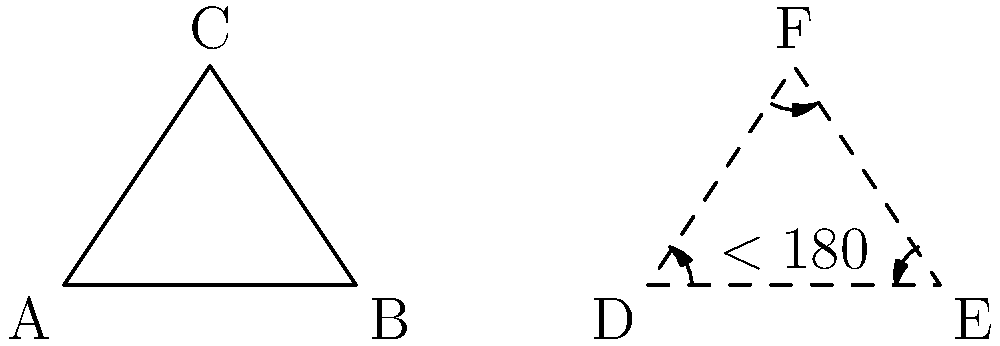En la geometría hiperbólica, ¿cómo se compara la suma de los ángulos internos de un triángulo con la de un triángulo euclidiano? Explique la diferencia y su significado en el contexto de la literatura de Eulalia Bernard. Para responder a esta pregunta, sigamos estos pasos:

1) En la geometría euclidiana:
   - La suma de los ángulos internos de un triángulo siempre es 180°.
   - Esto se representa en el triángulo ABC en la figura.

2) En la geometría hiperbólica:
   - La suma de los ángulos internos de un triángulo es siempre menor que 180°.
   - Esto se muestra en el triángulo DEF (línea punteada) en la figura.

3) Diferencia clave:
   - En la geometría hiperbólica, la suma de los ángulos depende del tamaño del triángulo.
   - Cuanto más grande sea el triángulo, menor será la suma de sus ángulos internos.

4) Significado en el contexto de Eulalia Bernard:
   - Bernard, como poeta afrocaribeña, a menudo explora temas de identidad y perspectiva.
   - La geometría hiperbólica puede ser una metáfora de cómo las perspectivas pueden cambiar según el contexto (tamaño del triángulo).
   - Así como los ángulos en la geometría hiperbólica desafían nuestras expectativas euclidianas, Bernard desafía las perspectivas convencionales en su literatura.

5) Conexión literaria:
   - La suma de ángulos menor que 180° en geometría hiperbólica puede representar la idea de Bernard de que las experiencias afrocaribeñas no siempre se ajustan a las "normas" establecidas.
   - La variabilidad de la suma de los ángulos puede simbolizar la diversidad de experiencias que Bernard describe en su poesía.
Answer: En geometría hiperbólica, la suma es $<180°$, variando según el tamaño del triángulo, reflejando la perspectiva no convencional en la literatura de Bernard. 